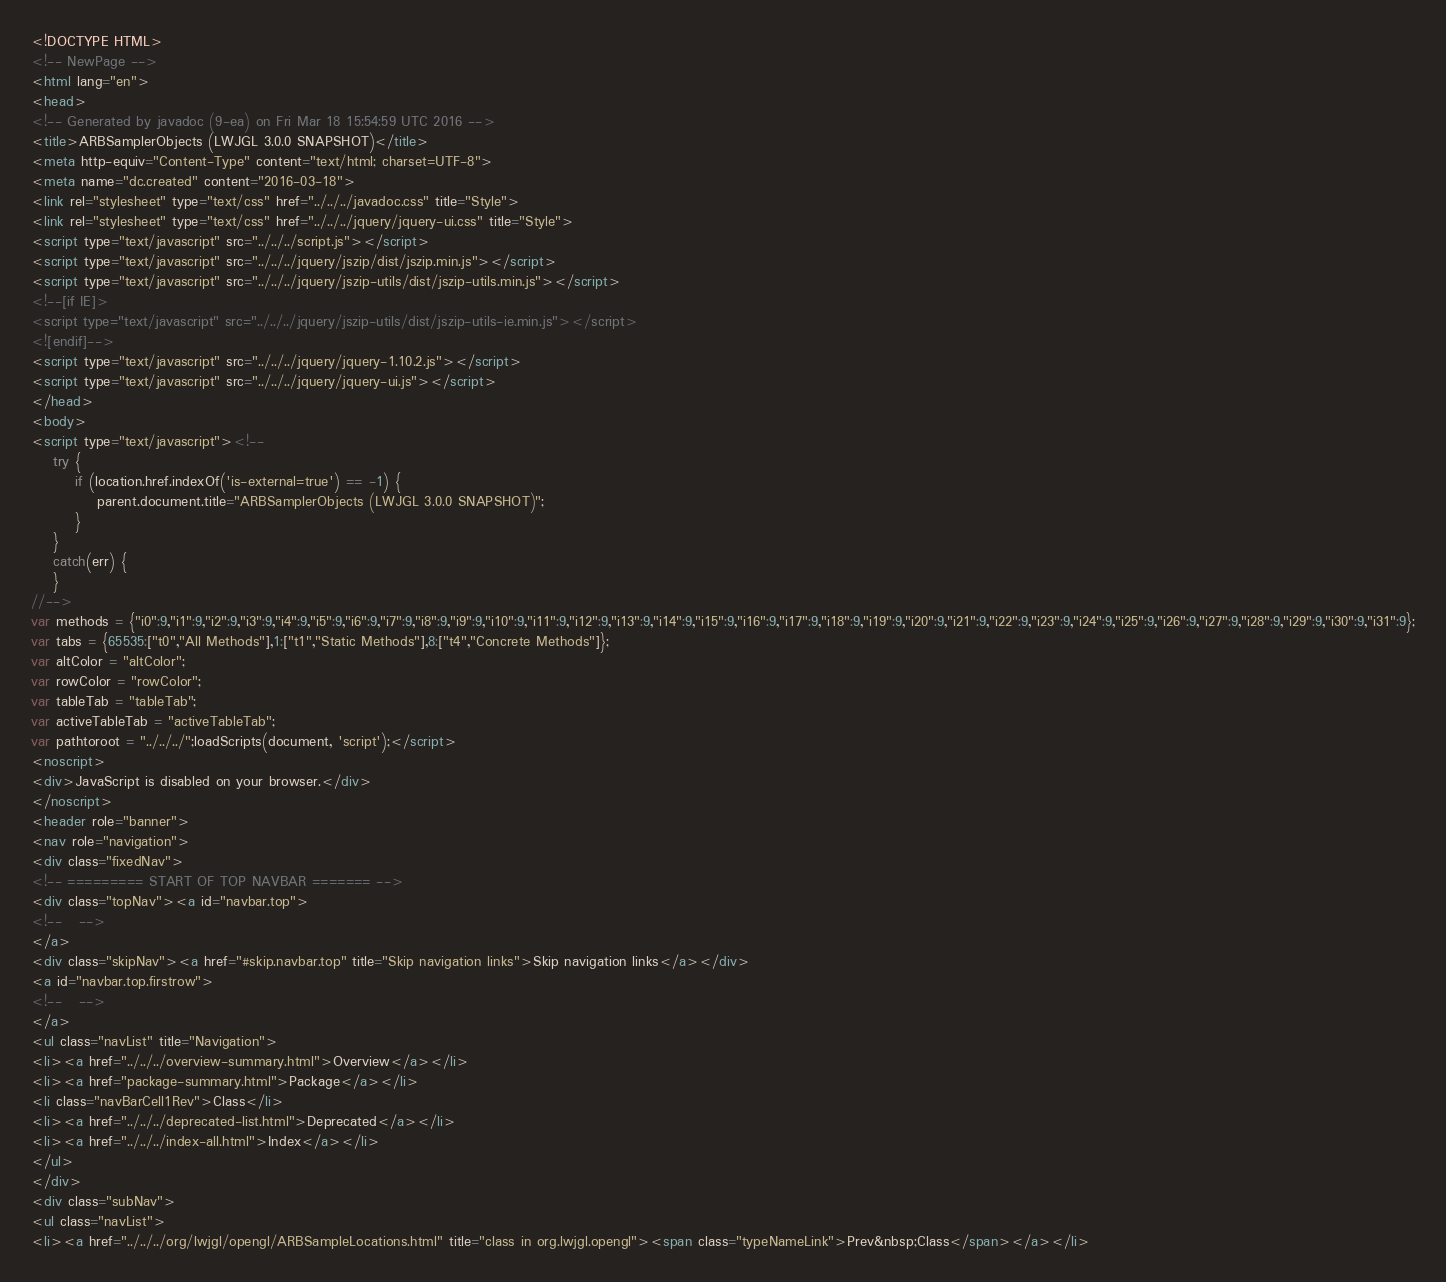<code> <loc_0><loc_0><loc_500><loc_500><_HTML_><!DOCTYPE HTML>
<!-- NewPage -->
<html lang="en">
<head>
<!-- Generated by javadoc (9-ea) on Fri Mar 18 15:54:59 UTC 2016 -->
<title>ARBSamplerObjects (LWJGL 3.0.0 SNAPSHOT)</title>
<meta http-equiv="Content-Type" content="text/html; charset=UTF-8">
<meta name="dc.created" content="2016-03-18">
<link rel="stylesheet" type="text/css" href="../../../javadoc.css" title="Style">
<link rel="stylesheet" type="text/css" href="../../../jquery/jquery-ui.css" title="Style">
<script type="text/javascript" src="../../../script.js"></script>
<script type="text/javascript" src="../../../jquery/jszip/dist/jszip.min.js"></script>
<script type="text/javascript" src="../../../jquery/jszip-utils/dist/jszip-utils.min.js"></script>
<!--[if IE]>
<script type="text/javascript" src="../../../jquery/jszip-utils/dist/jszip-utils-ie.min.js"></script>
<![endif]-->
<script type="text/javascript" src="../../../jquery/jquery-1.10.2.js"></script>
<script type="text/javascript" src="../../../jquery/jquery-ui.js"></script>
</head>
<body>
<script type="text/javascript"><!--
    try {
        if (location.href.indexOf('is-external=true') == -1) {
            parent.document.title="ARBSamplerObjects (LWJGL 3.0.0 SNAPSHOT)";
        }
    }
    catch(err) {
    }
//-->
var methods = {"i0":9,"i1":9,"i2":9,"i3":9,"i4":9,"i5":9,"i6":9,"i7":9,"i8":9,"i9":9,"i10":9,"i11":9,"i12":9,"i13":9,"i14":9,"i15":9,"i16":9,"i17":9,"i18":9,"i19":9,"i20":9,"i21":9,"i22":9,"i23":9,"i24":9,"i25":9,"i26":9,"i27":9,"i28":9,"i29":9,"i30":9,"i31":9};
var tabs = {65535:["t0","All Methods"],1:["t1","Static Methods"],8:["t4","Concrete Methods"]};
var altColor = "altColor";
var rowColor = "rowColor";
var tableTab = "tableTab";
var activeTableTab = "activeTableTab";
var pathtoroot = "../../../";loadScripts(document, 'script');</script>
<noscript>
<div>JavaScript is disabled on your browser.</div>
</noscript>
<header role="banner">
<nav role="navigation">
<div class="fixedNav">
<!-- ========= START OF TOP NAVBAR ======= -->
<div class="topNav"><a id="navbar.top">
<!--   -->
</a>
<div class="skipNav"><a href="#skip.navbar.top" title="Skip navigation links">Skip navigation links</a></div>
<a id="navbar.top.firstrow">
<!--   -->
</a>
<ul class="navList" title="Navigation">
<li><a href="../../../overview-summary.html">Overview</a></li>
<li><a href="package-summary.html">Package</a></li>
<li class="navBarCell1Rev">Class</li>
<li><a href="../../../deprecated-list.html">Deprecated</a></li>
<li><a href="../../../index-all.html">Index</a></li>
</ul>
</div>
<div class="subNav">
<ul class="navList">
<li><a href="../../../org/lwjgl/opengl/ARBSampleLocations.html" title="class in org.lwjgl.opengl"><span class="typeNameLink">Prev&nbsp;Class</span></a></li></code> 